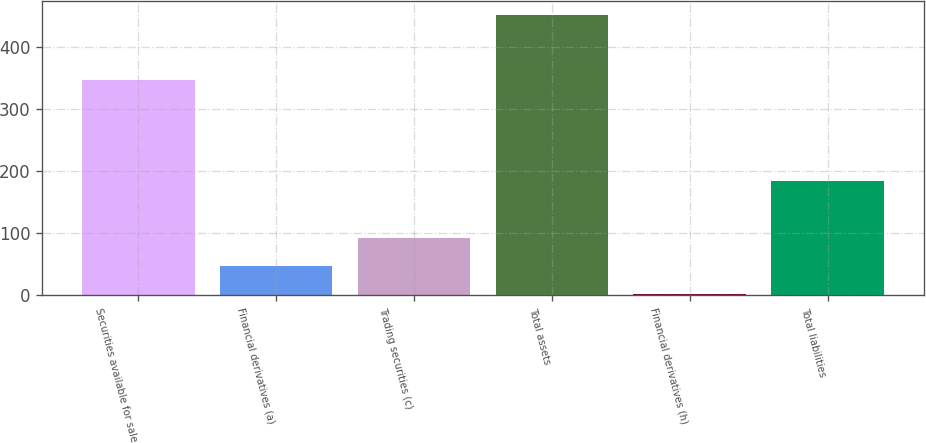Convert chart to OTSL. <chart><loc_0><loc_0><loc_500><loc_500><bar_chart><fcel>Securities available for sale<fcel>Financial derivatives (a)<fcel>Trading securities (c)<fcel>Total assets<fcel>Financial derivatives (h)<fcel>Total liabilities<nl><fcel>347<fcel>47<fcel>92<fcel>452<fcel>2<fcel>184<nl></chart> 